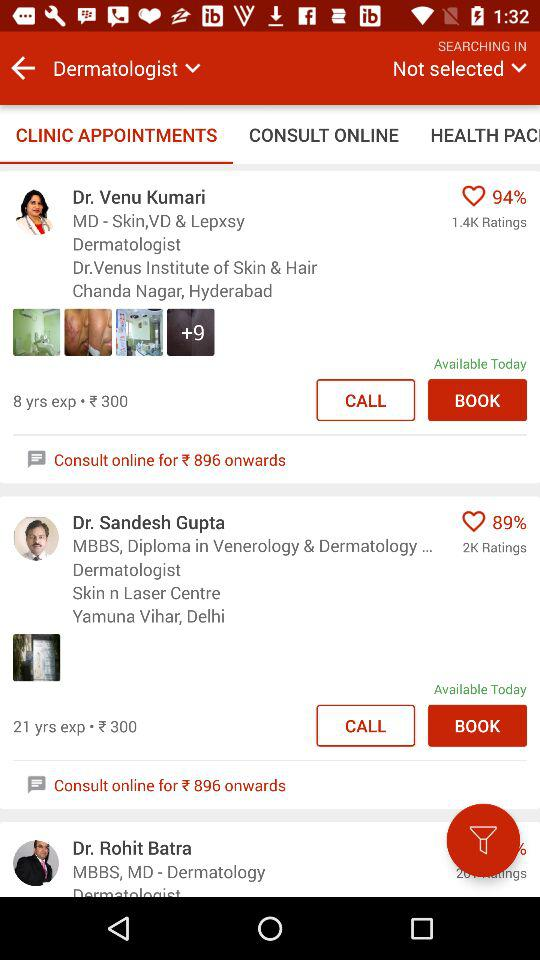How many years of experience does Dr. Venu Kumari have? Dr. Venu Kumari has 8 years of experience. 